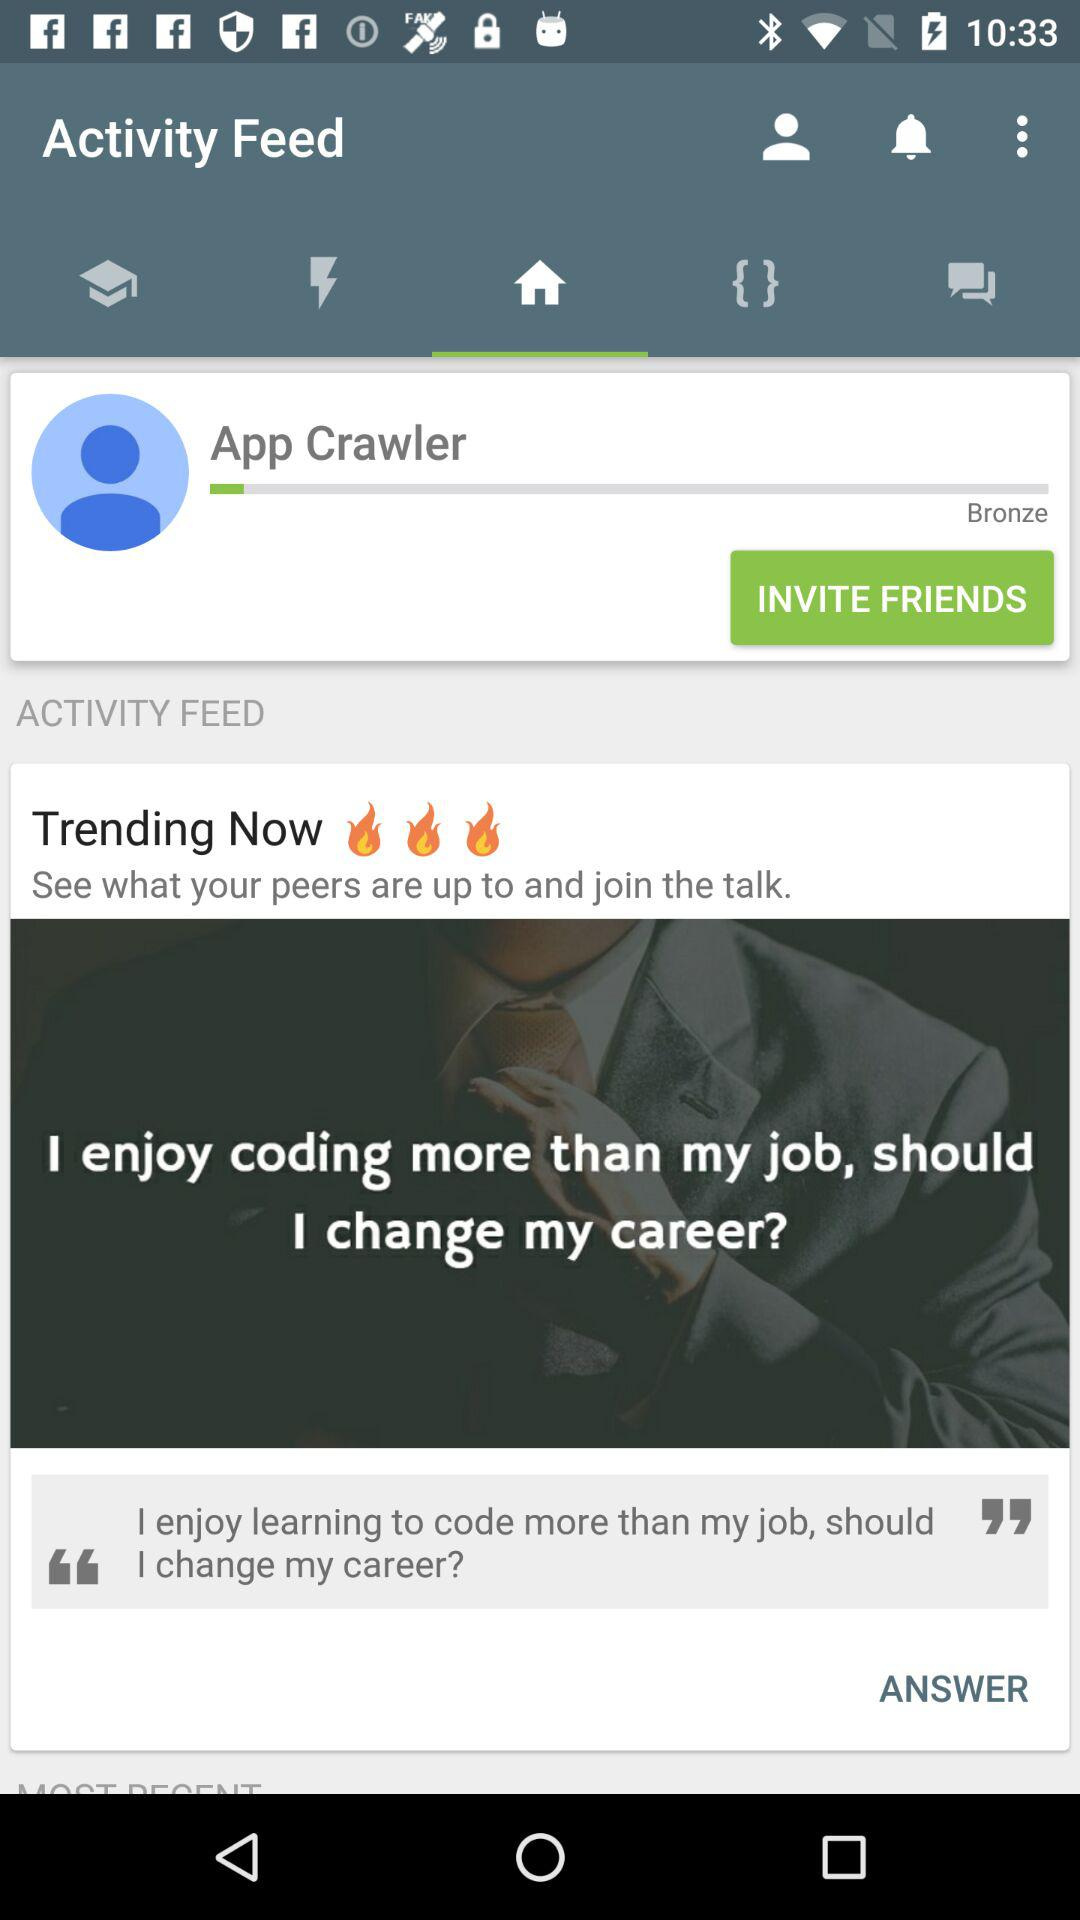What is the name? The name is App Crawler. 